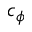Convert formula to latex. <formula><loc_0><loc_0><loc_500><loc_500>c _ { \phi }</formula> 